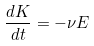<formula> <loc_0><loc_0><loc_500><loc_500>\frac { d K } { d t } = - \nu E</formula> 